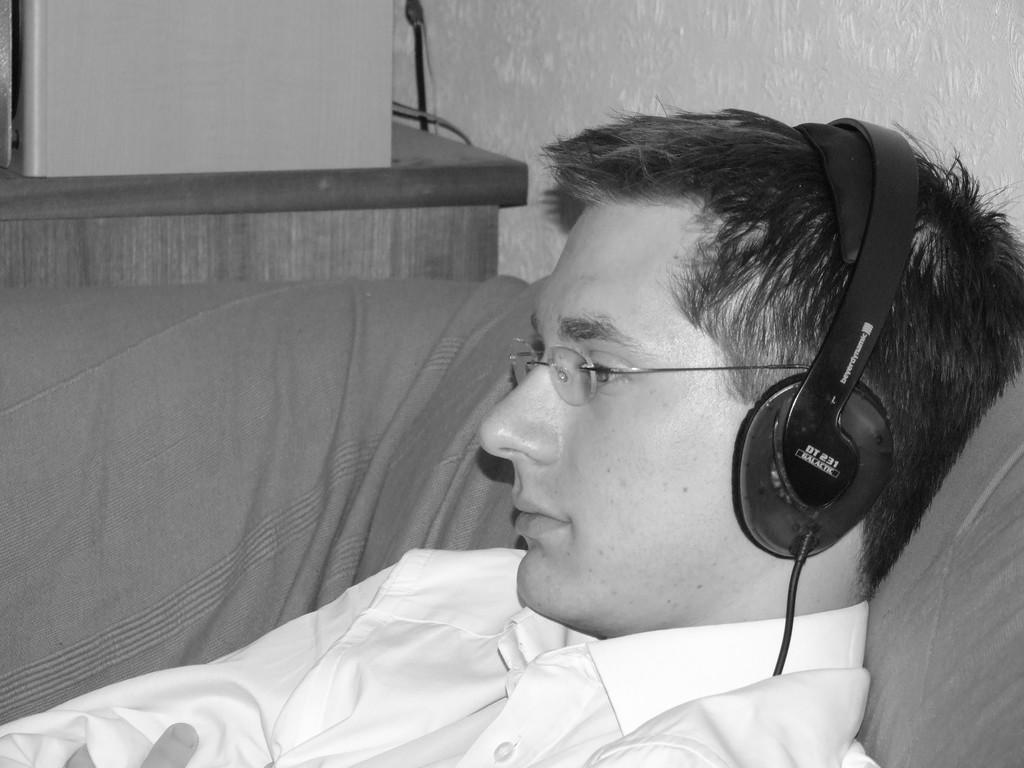What is the man in the image doing? The man is sitting on a sofa. What can be seen on or near the man in the image? There is a headphone in the image. What is located on the table in the image? There is an object on a table. What is visible in the background of the image? There is a wall in the image. What type of treatment is the man receiving at the seashore in the image? There is no seashore present in the image, and the man is not receiving any treatment. 